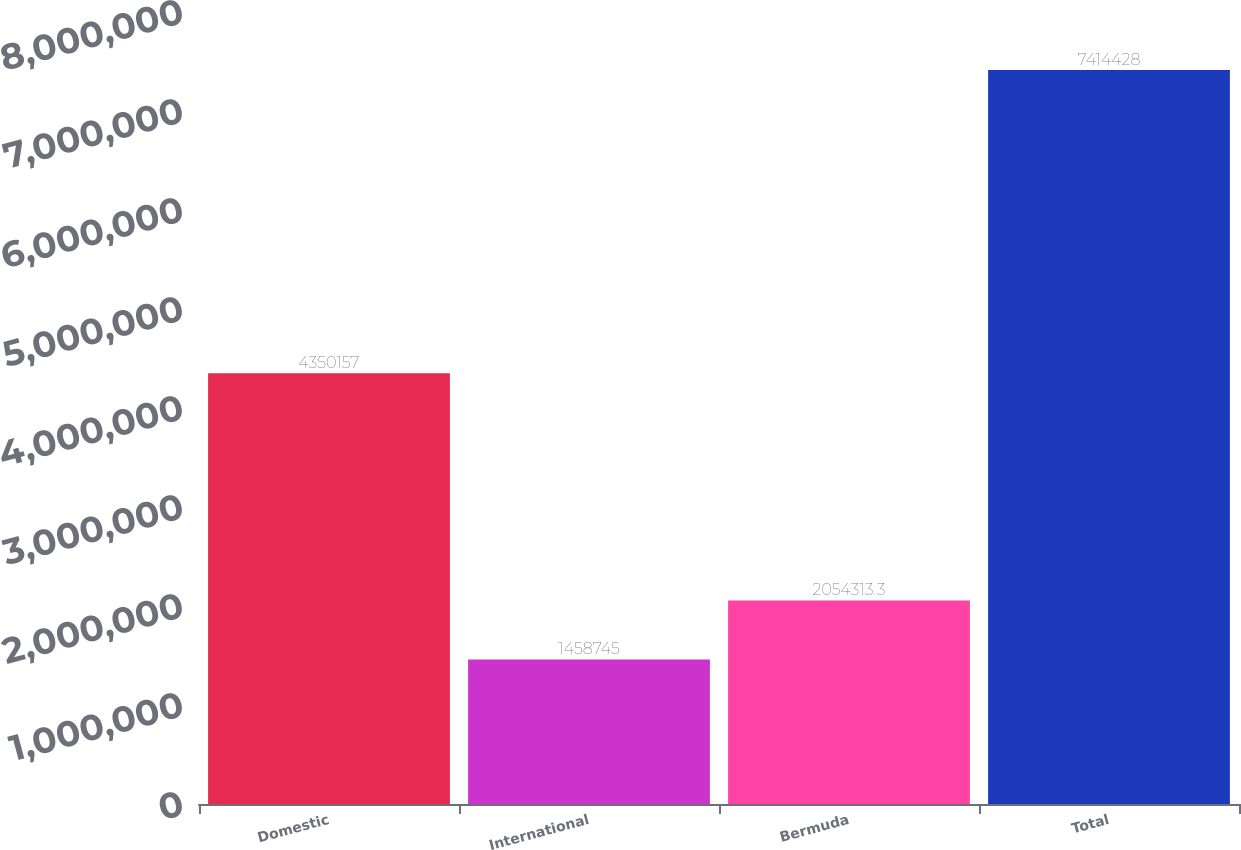Convert chart to OTSL. <chart><loc_0><loc_0><loc_500><loc_500><bar_chart><fcel>Domestic<fcel>International<fcel>Bermuda<fcel>Total<nl><fcel>4.35016e+06<fcel>1.45874e+06<fcel>2.05431e+06<fcel>7.41443e+06<nl></chart> 